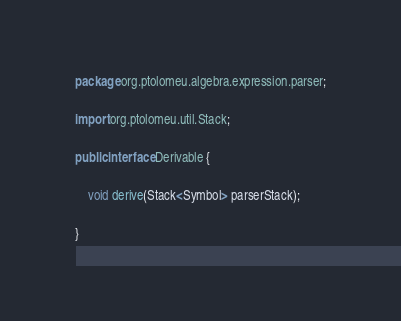Convert code to text. <code><loc_0><loc_0><loc_500><loc_500><_Java_>package org.ptolomeu.algebra.expression.parser;

import org.ptolomeu.util.Stack;

public interface Derivable {

    void derive(Stack<Symbol> parserStack);

}
</code> 